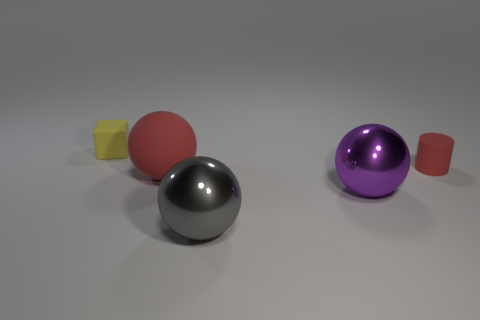What number of cylinders are green metallic objects or small objects?
Keep it short and to the point. 1. Is there a tiny blue thing of the same shape as the gray object?
Keep it short and to the point. No. There is a tiny red thing; what shape is it?
Offer a very short reply. Cylinder. What number of objects are either gray shiny objects or green cylinders?
Make the answer very short. 1. Do the rubber thing that is on the right side of the large red ball and the rubber object that is left of the large red thing have the same size?
Offer a very short reply. Yes. What number of other things are the same material as the big purple thing?
Keep it short and to the point. 1. Is the number of shiny objects behind the purple shiny ball greater than the number of small yellow things behind the large gray metal sphere?
Give a very brief answer. No. There is a small thing that is on the left side of the small red matte cylinder; what material is it?
Ensure brevity in your answer.  Rubber. Do the gray thing and the big matte object have the same shape?
Give a very brief answer. Yes. Are there any other things that have the same color as the tiny block?
Provide a short and direct response. No. 